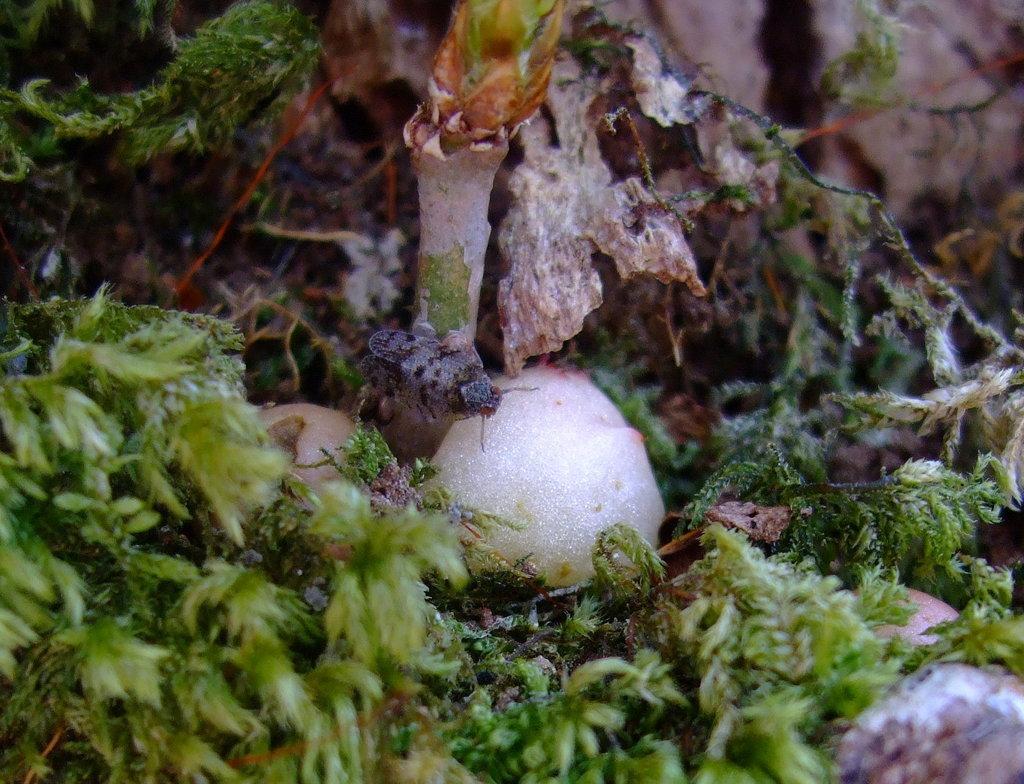Could you give a brief overview of what you see in this image? At the bottom of this image I can see few leaves of a plant. In the middle of this image I can see an insect on a white color stone. 